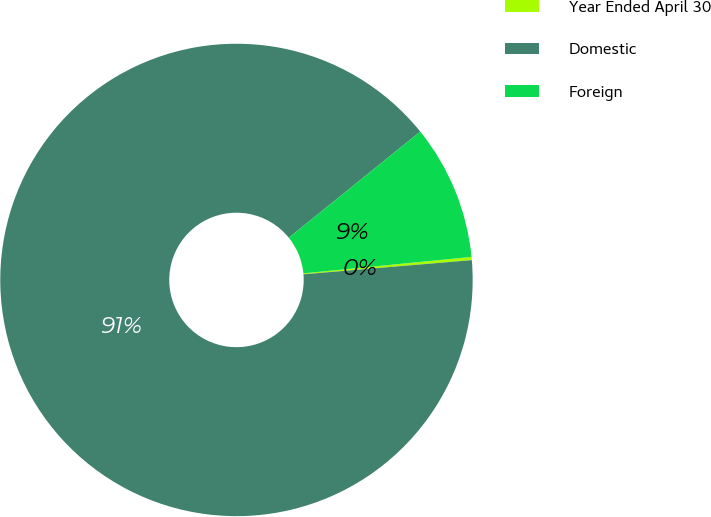<chart> <loc_0><loc_0><loc_500><loc_500><pie_chart><fcel>Year Ended April 30<fcel>Domestic<fcel>Foreign<nl><fcel>0.22%<fcel>90.52%<fcel>9.25%<nl></chart> 